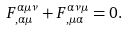Convert formula to latex. <formula><loc_0><loc_0><loc_500><loc_500>F _ { , \alpha \mu } ^ { \alpha \mu \nu } + F _ { , \mu \alpha } ^ { \alpha \nu \mu } = 0 .</formula> 